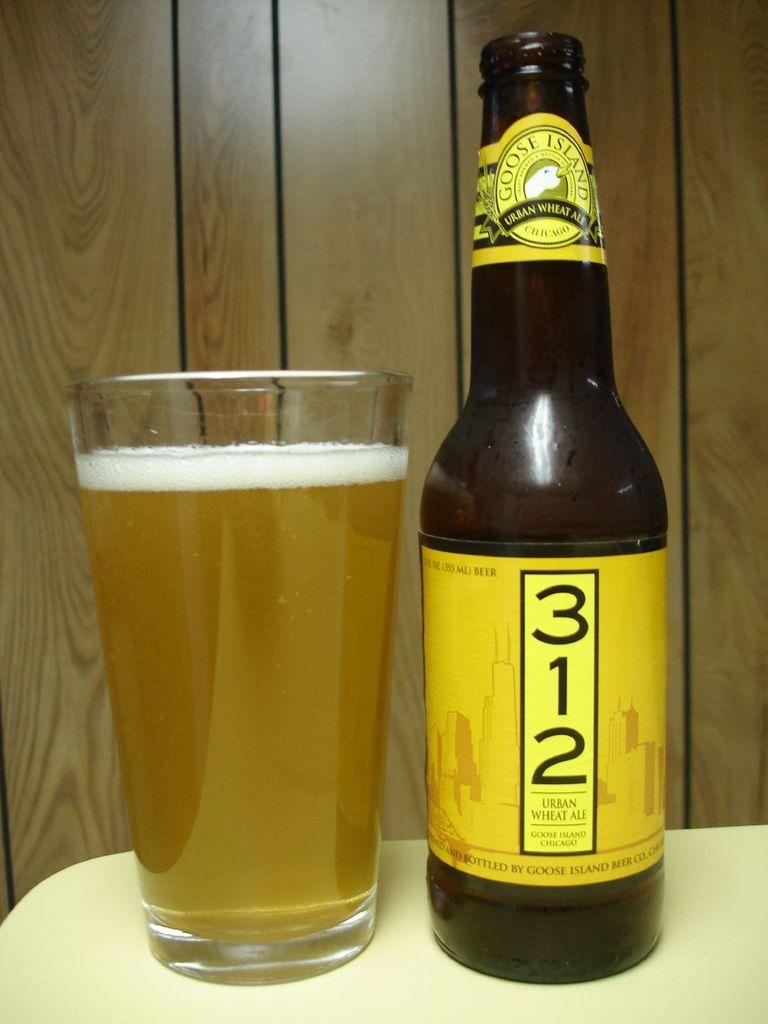What number bottle is this?
Provide a short and direct response. 312. What brand of beer is this?
Your response must be concise. 312. 